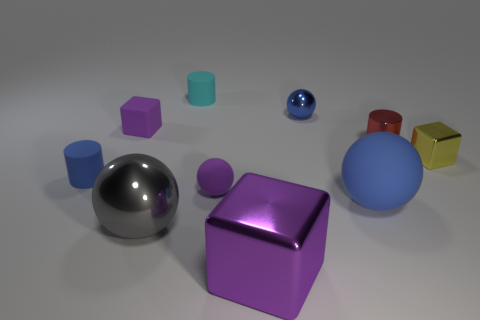How many objects are blocks on the left side of the large purple metal cube or cubes in front of the small yellow thing?
Provide a succinct answer. 2. Do the tiny cylinder in front of the yellow metal block and the tiny purple object that is in front of the yellow metallic block have the same material?
Your response must be concise. Yes. The blue matte object that is to the left of the big shiny thing that is behind the large purple object is what shape?
Make the answer very short. Cylinder. Is there any other thing that has the same color as the tiny shiny cylinder?
Provide a succinct answer. No. Are there any red objects that are behind the purple matte object in front of the purple matte object that is behind the yellow shiny cube?
Offer a terse response. Yes. There is a small shiny thing on the left side of the tiny red cylinder; is its color the same as the metallic thing on the left side of the cyan matte cylinder?
Ensure brevity in your answer.  No. What is the material of the cyan object that is the same size as the red shiny cylinder?
Your response must be concise. Rubber. What is the size of the purple cube that is in front of the blue thing to the left of the purple cube that is in front of the yellow metallic object?
Provide a short and direct response. Large. How many other objects are there of the same material as the gray sphere?
Your response must be concise. 4. How big is the rubber object behind the blue metal ball?
Offer a terse response. Small. 